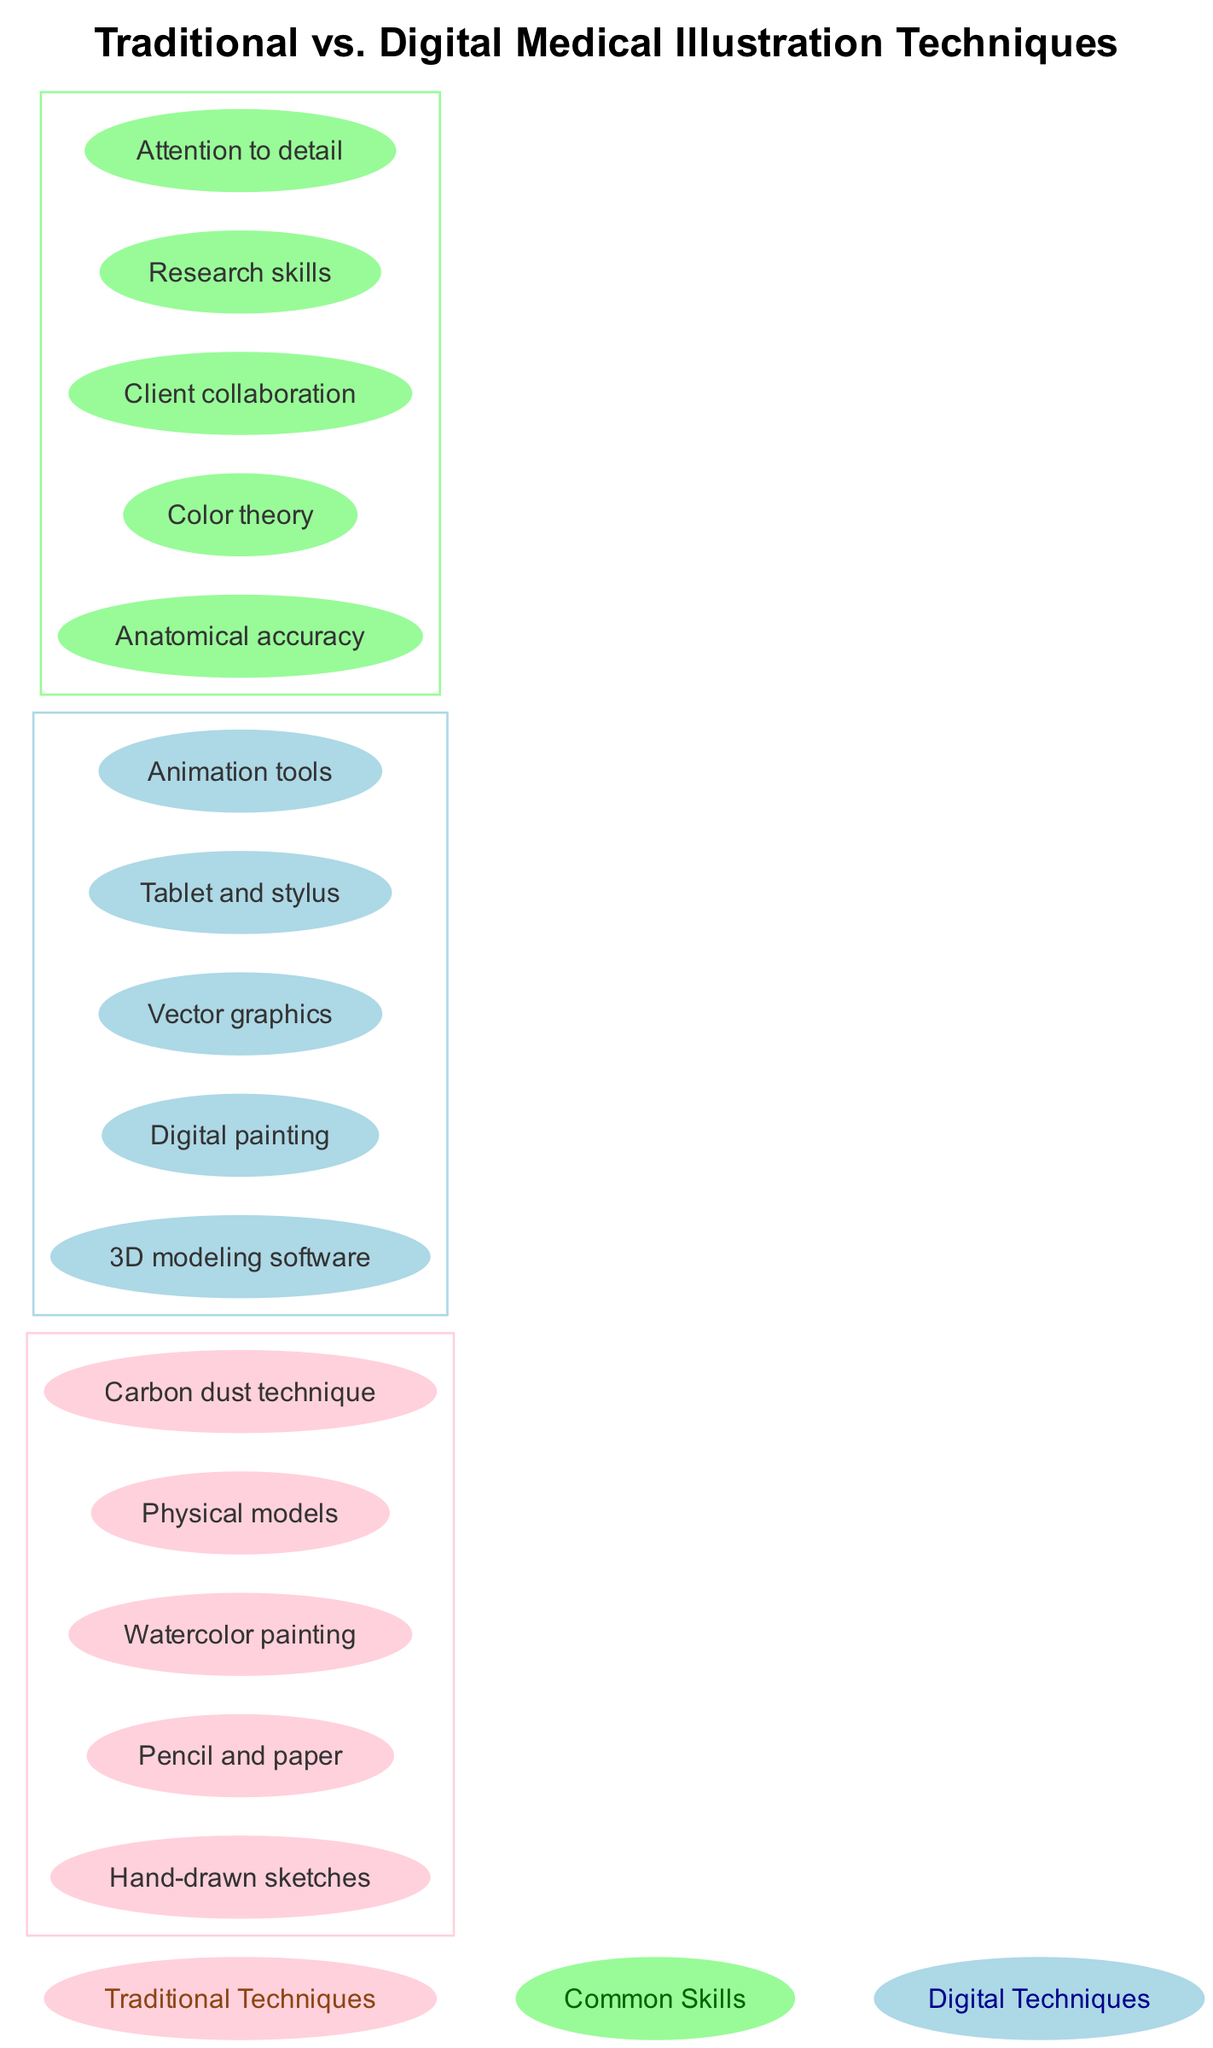What are two traditional techniques listed in the diagram? The diagram lists five elements under the traditional techniques set. Two of these elements are "Hand-drawn sketches" and "Watercolor painting."
Answer: Hand-drawn sketches, Watercolor painting How many digital techniques are shown in the diagram? There are five elements listed under the digital techniques set. Thus, the total count of digital techniques in the diagram is five.
Answer: 5 What is the common skill mentioned in the intersection? The diagram shows several common skills, one of which is "Anatomical accuracy," clearly listed in the intersection between the two sets.
Answer: Anatomical accuracy Which technique uses a pencil and paper? The term "Pencil and paper" is explicitly stated as one of the elements in the traditional techniques set within the diagram.
Answer: Pencil and paper What color represents digital techniques in the diagram? In the diagram, digital techniques are represented by the color light blue, which is associated with the set labeled "Digital."
Answer: Light blue How many common skills are listed in the intersection? The intersection node contains a total of five skills that are common to both traditional and digital techniques, as noted in the diagram.
Answer: 5 Which technique is specifically used for creating animations? The diagram indicates "Animation tools" as one of the elements in the digital techniques set that is specifically for creating animations.
Answer: Animation tools What type of software is used in digital techniques according to the diagram? The diagram indicates "3D modeling software" as one of the techniques under the digital category, which is used for creating digital illustrations.
Answer: 3D modeling software What shared skill involves working with clients? "Client collaboration" is listed in the intersection of the diagram, indicating it is a shared skill between traditional and digital medical illustration methods.
Answer: Client collaboration 